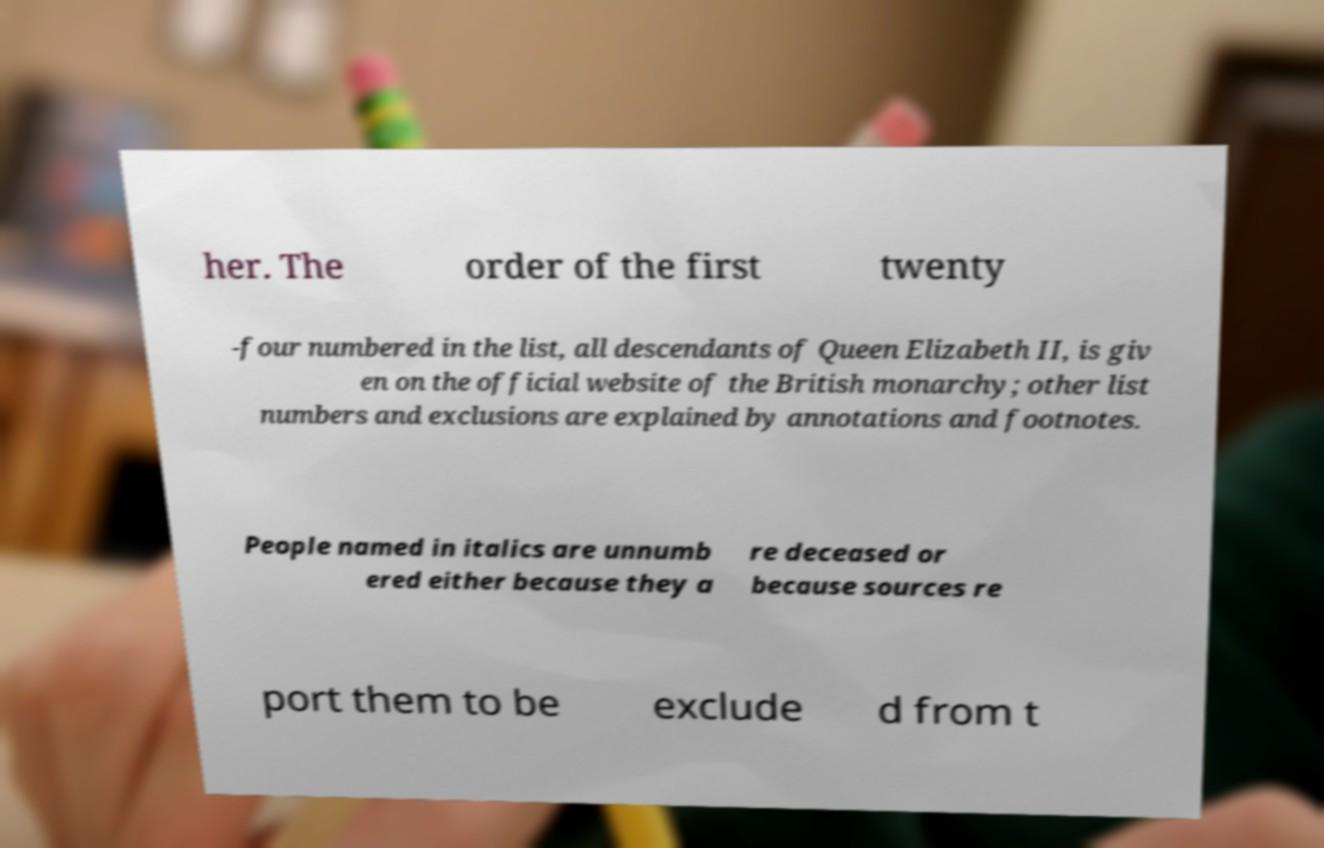What messages or text are displayed in this image? I need them in a readable, typed format. her. The order of the first twenty -four numbered in the list, all descendants of Queen Elizabeth II, is giv en on the official website of the British monarchy; other list numbers and exclusions are explained by annotations and footnotes. People named in italics are unnumb ered either because they a re deceased or because sources re port them to be exclude d from t 